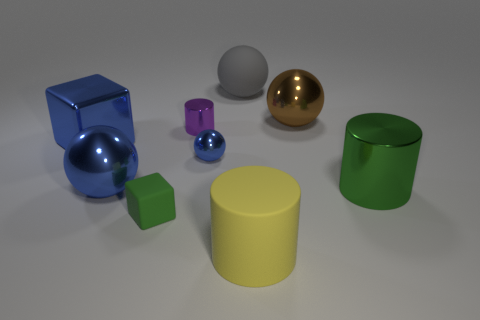What number of things are big gray rubber cylinders or big objects that are on the right side of the small cylinder? In the image, there are two objects that fit the description of being big and gray cylinders. Additionally, there are two objects to the right side of the small cylinder, making a total of four big objects as per the criteria provided. 